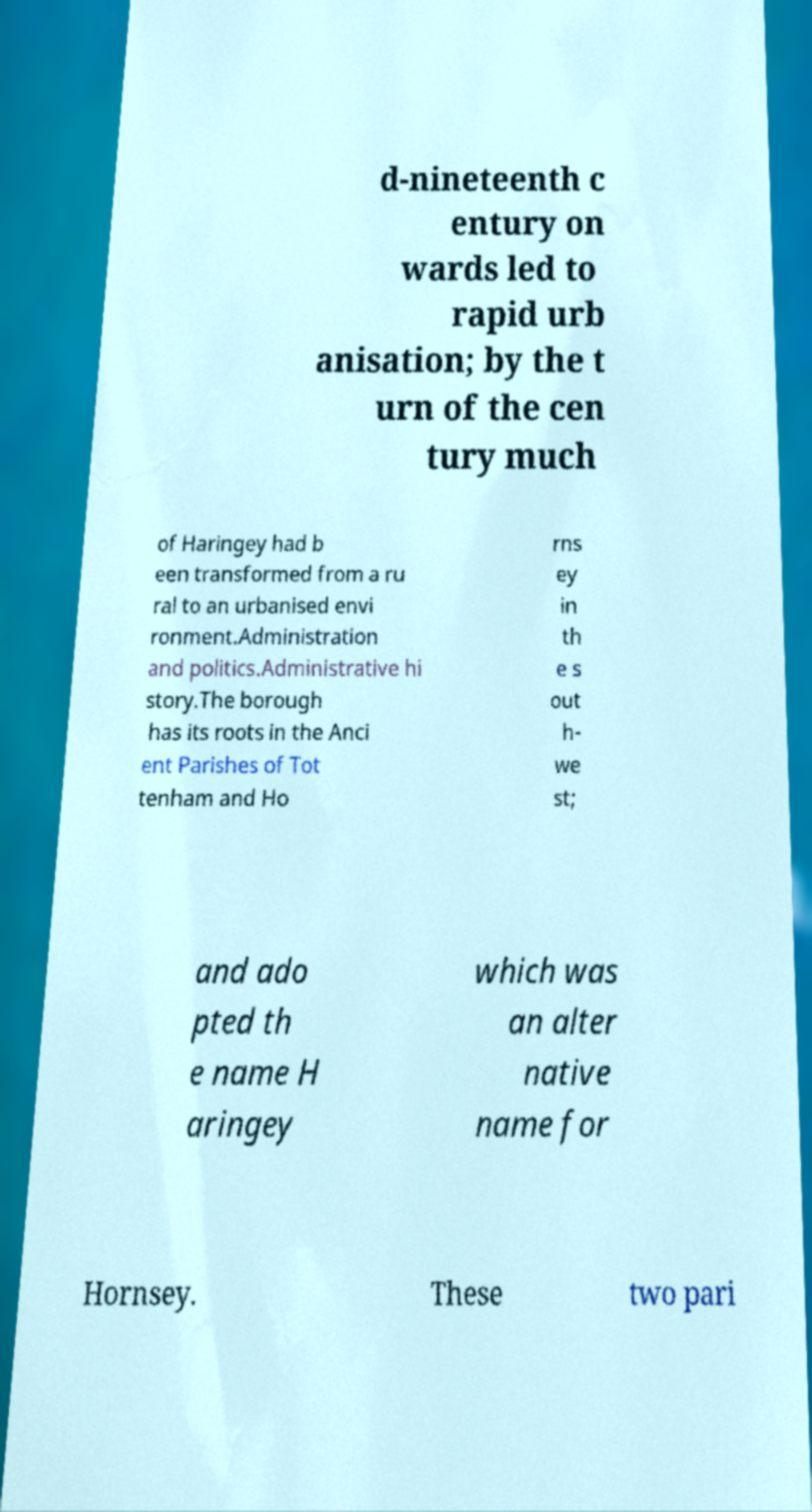Can you accurately transcribe the text from the provided image for me? d-nineteenth c entury on wards led to rapid urb anisation; by the t urn of the cen tury much of Haringey had b een transformed from a ru ral to an urbanised envi ronment.Administration and politics.Administrative hi story.The borough has its roots in the Anci ent Parishes of Tot tenham and Ho rns ey in th e s out h- we st; and ado pted th e name H aringey which was an alter native name for Hornsey. These two pari 